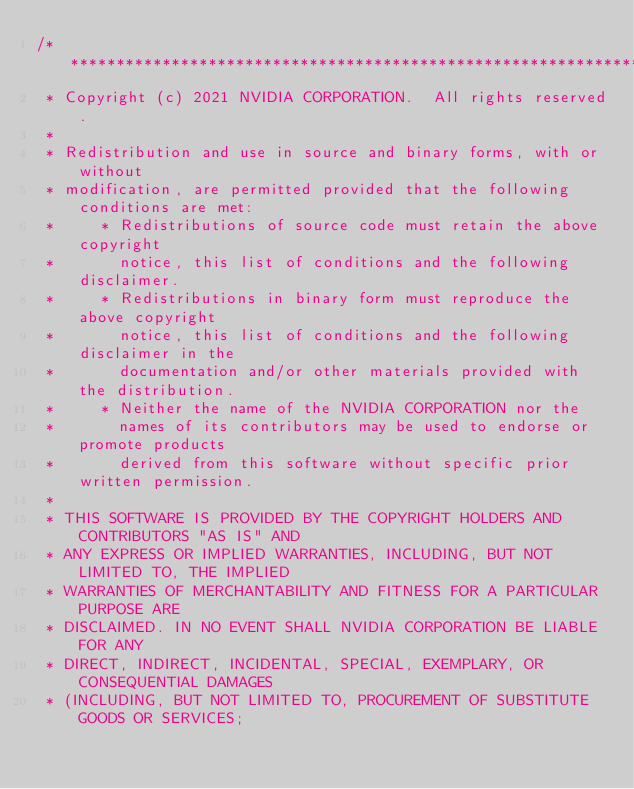<code> <loc_0><loc_0><loc_500><loc_500><_Cuda_>/******************************************************************************
 * Copyright (c) 2021 NVIDIA CORPORATION.  All rights reserved.
 *
 * Redistribution and use in source and binary forms, with or without
 * modification, are permitted provided that the following conditions are met:
 *     * Redistributions of source code must retain the above copyright
 *       notice, this list of conditions and the following disclaimer.
 *     * Redistributions in binary form must reproduce the above copyright
 *       notice, this list of conditions and the following disclaimer in the
 *       documentation and/or other materials provided with the distribution.
 *     * Neither the name of the NVIDIA CORPORATION nor the
 *       names of its contributors may be used to endorse or promote products
 *       derived from this software without specific prior written permission.
 *
 * THIS SOFTWARE IS PROVIDED BY THE COPYRIGHT HOLDERS AND CONTRIBUTORS "AS IS" AND
 * ANY EXPRESS OR IMPLIED WARRANTIES, INCLUDING, BUT NOT LIMITED TO, THE IMPLIED
 * WARRANTIES OF MERCHANTABILITY AND FITNESS FOR A PARTICULAR PURPOSE ARE
 * DISCLAIMED. IN NO EVENT SHALL NVIDIA CORPORATION BE LIABLE FOR ANY
 * DIRECT, INDIRECT, INCIDENTAL, SPECIAL, EXEMPLARY, OR CONSEQUENTIAL DAMAGES
 * (INCLUDING, BUT NOT LIMITED TO, PROCUREMENT OF SUBSTITUTE GOODS OR SERVICES;</code> 